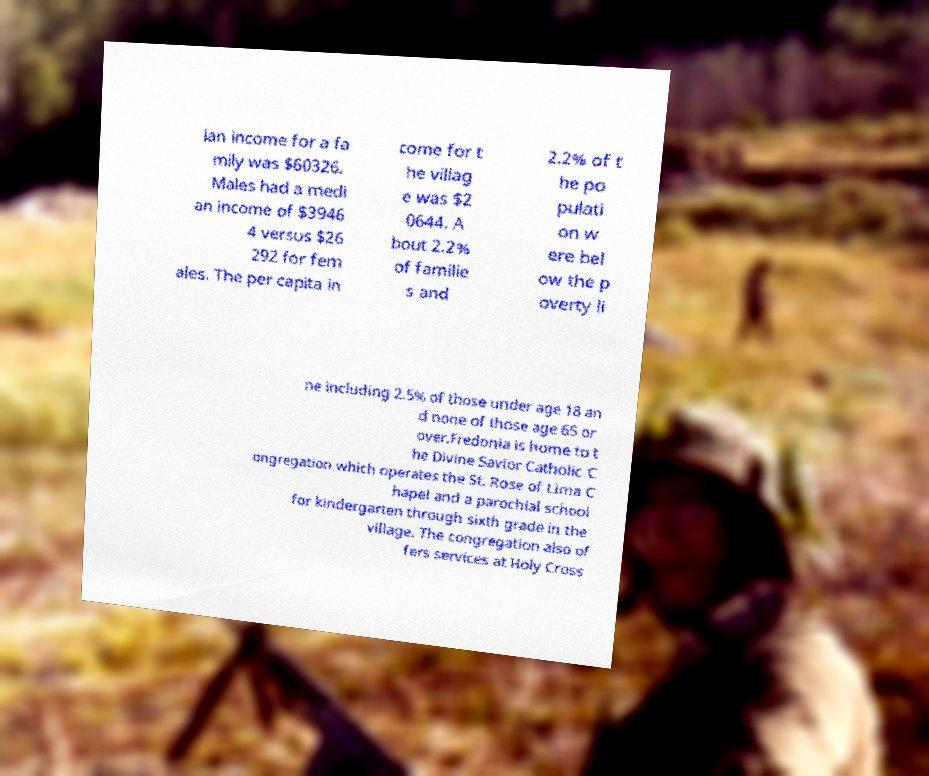Could you assist in decoding the text presented in this image and type it out clearly? ian income for a fa mily was $60326. Males had a medi an income of $3946 4 versus $26 292 for fem ales. The per capita in come for t he villag e was $2 0644. A bout 2.2% of familie s and 2.2% of t he po pulati on w ere bel ow the p overty li ne including 2.5% of those under age 18 an d none of those age 65 or over.Fredonia is home to t he Divine Savior Catholic C ongregation which operates the St. Rose of Lima C hapel and a parochial school for kindergarten through sixth grade in the village. The congregation also of fers services at Holy Cross 